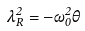Convert formula to latex. <formula><loc_0><loc_0><loc_500><loc_500>\lambda _ { R } ^ { 2 } = - \omega _ { 0 } ^ { 2 } \theta</formula> 